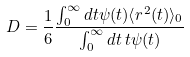Convert formula to latex. <formula><loc_0><loc_0><loc_500><loc_500>D = \frac { 1 } { 6 } \frac { \int _ { 0 } ^ { \infty } d t \psi ( t ) \langle r ^ { 2 } ( t ) \rangle _ { 0 } } { \int _ { 0 } ^ { \infty } d t \, t \psi ( t ) }</formula> 